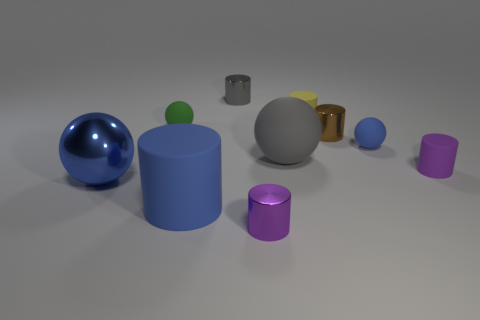Subtract all blue cylinders. How many cylinders are left? 5 Subtract all brown cylinders. How many cylinders are left? 5 Subtract 3 cylinders. How many cylinders are left? 3 Subtract all gray cylinders. Subtract all brown balls. How many cylinders are left? 5 Subtract all balls. How many objects are left? 6 Add 1 blue shiny things. How many blue shiny things exist? 2 Subtract 0 brown blocks. How many objects are left? 10 Subtract all gray objects. Subtract all small gray things. How many objects are left? 7 Add 6 gray metal cylinders. How many gray metal cylinders are left? 7 